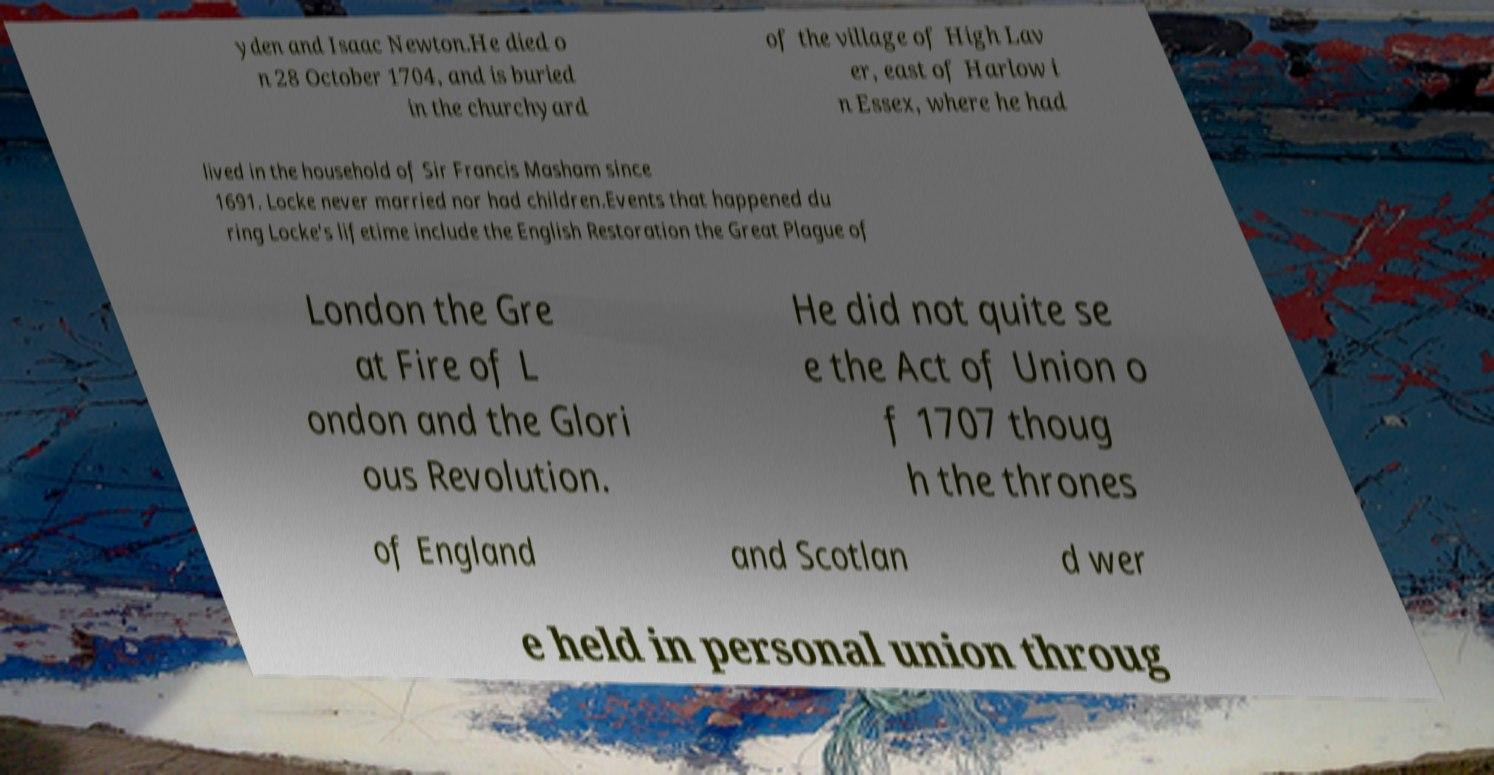Can you read and provide the text displayed in the image?This photo seems to have some interesting text. Can you extract and type it out for me? yden and Isaac Newton.He died o n 28 October 1704, and is buried in the churchyard of the village of High Lav er, east of Harlow i n Essex, where he had lived in the household of Sir Francis Masham since 1691. Locke never married nor had children.Events that happened du ring Locke's lifetime include the English Restoration the Great Plague of London the Gre at Fire of L ondon and the Glori ous Revolution. He did not quite se e the Act of Union o f 1707 thoug h the thrones of England and Scotlan d wer e held in personal union throug 